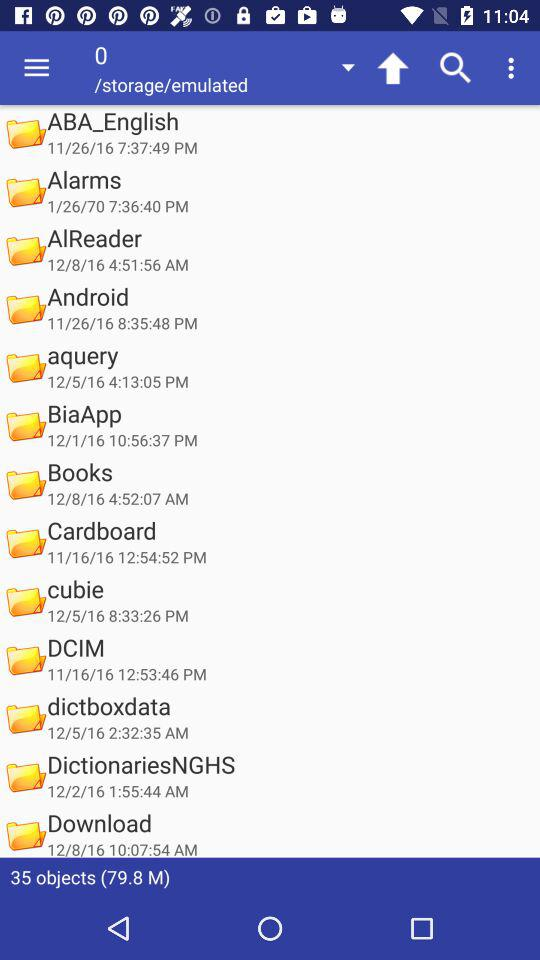On which date was "DCIM" folder created? "DCIM" folder was created on November 16, 2016. 